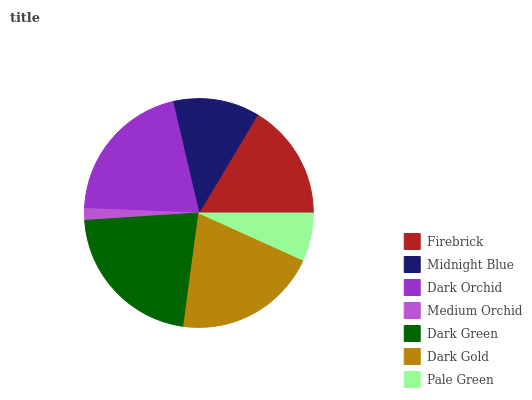Is Medium Orchid the minimum?
Answer yes or no. Yes. Is Dark Green the maximum?
Answer yes or no. Yes. Is Midnight Blue the minimum?
Answer yes or no. No. Is Midnight Blue the maximum?
Answer yes or no. No. Is Firebrick greater than Midnight Blue?
Answer yes or no. Yes. Is Midnight Blue less than Firebrick?
Answer yes or no. Yes. Is Midnight Blue greater than Firebrick?
Answer yes or no. No. Is Firebrick less than Midnight Blue?
Answer yes or no. No. Is Firebrick the high median?
Answer yes or no. Yes. Is Firebrick the low median?
Answer yes or no. Yes. Is Medium Orchid the high median?
Answer yes or no. No. Is Midnight Blue the low median?
Answer yes or no. No. 